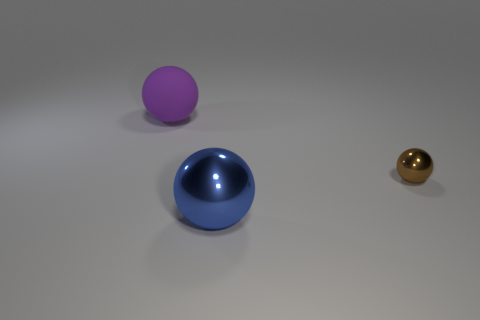What mood or atmosphere does the arrangement of the spheres convey? The image evokes a serene and minimalist atmosphere, with the clean lines and muted background emphasizing the simplicity and balance of the spheres' arrangement. 